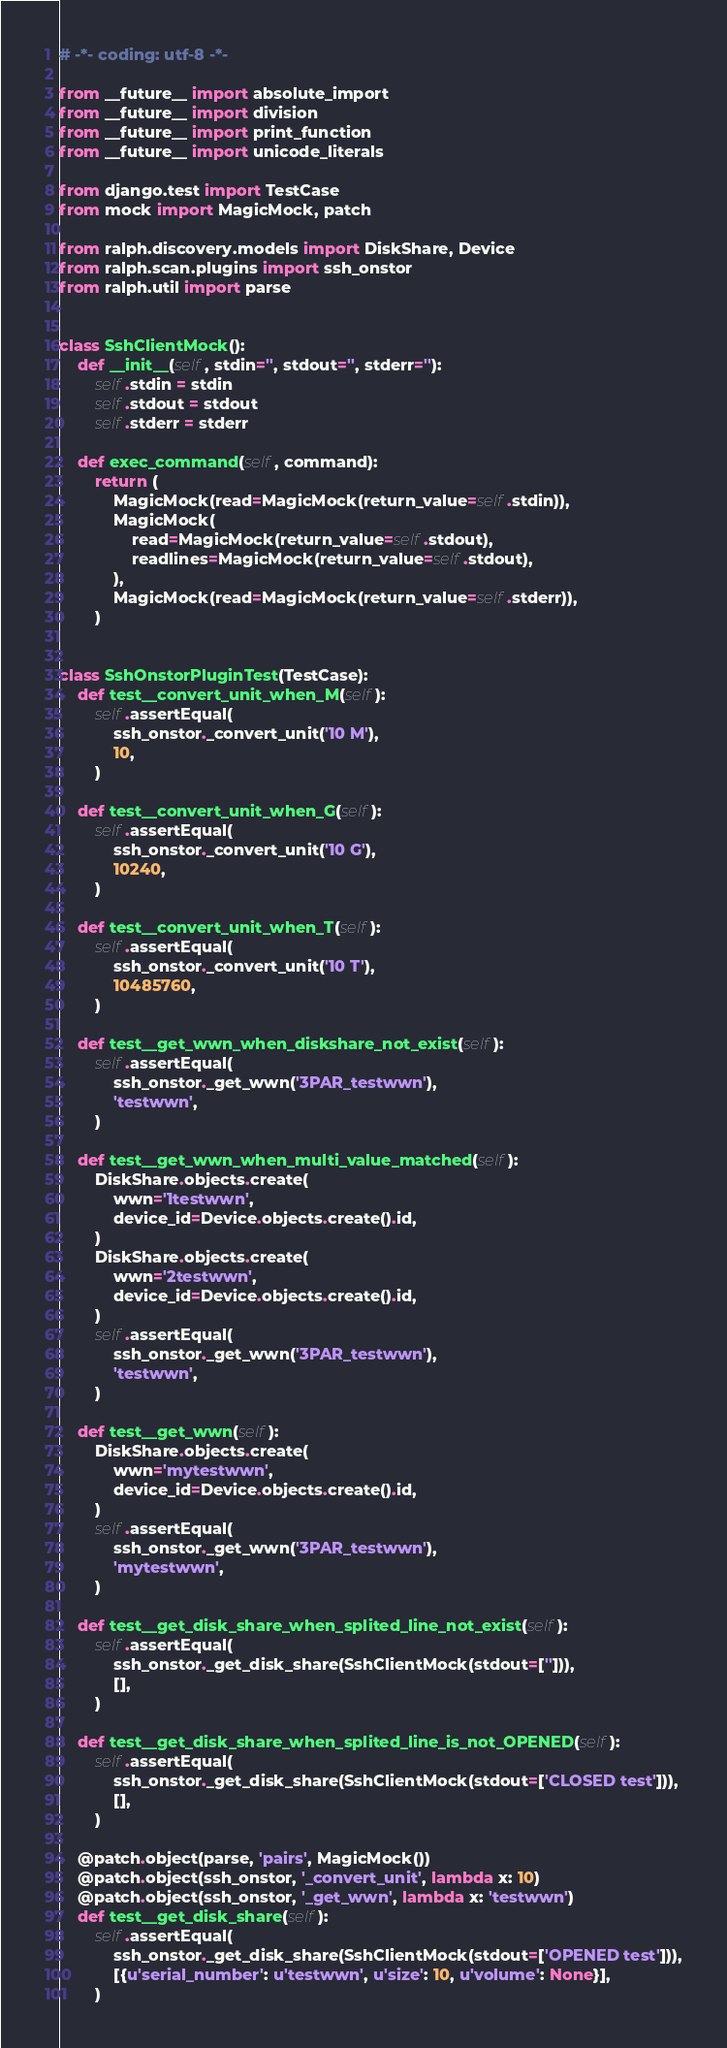Convert code to text. <code><loc_0><loc_0><loc_500><loc_500><_Python_># -*- coding: utf-8 -*-

from __future__ import absolute_import
from __future__ import division
from __future__ import print_function
from __future__ import unicode_literals

from django.test import TestCase
from mock import MagicMock, patch

from ralph.discovery.models import DiskShare, Device
from ralph.scan.plugins import ssh_onstor
from ralph.util import parse


class SshClientMock():
    def __init__(self, stdin='', stdout='', stderr=''):
        self.stdin = stdin
        self.stdout = stdout
        self.stderr = stderr

    def exec_command(self, command):
        return (
            MagicMock(read=MagicMock(return_value=self.stdin)),
            MagicMock(
                read=MagicMock(return_value=self.stdout),
                readlines=MagicMock(return_value=self.stdout),
            ),
            MagicMock(read=MagicMock(return_value=self.stderr)),
        )


class SshOnstorPluginTest(TestCase):
    def test__convert_unit_when_M(self):
        self.assertEqual(
            ssh_onstor._convert_unit('10 M'),
            10,
        )

    def test__convert_unit_when_G(self):
        self.assertEqual(
            ssh_onstor._convert_unit('10 G'),
            10240,
        )

    def test__convert_unit_when_T(self):
        self.assertEqual(
            ssh_onstor._convert_unit('10 T'),
            10485760,
        )

    def test__get_wwn_when_diskshare_not_exist(self):
        self.assertEqual(
            ssh_onstor._get_wwn('3PAR_testwwn'),
            'testwwn',
        )

    def test__get_wwn_when_multi_value_matched(self):
        DiskShare.objects.create(
            wwn='1testwwn',
            device_id=Device.objects.create().id,
        )
        DiskShare.objects.create(
            wwn='2testwwn',
            device_id=Device.objects.create().id,
        )
        self.assertEqual(
            ssh_onstor._get_wwn('3PAR_testwwn'),
            'testwwn',
        )

    def test__get_wwn(self):
        DiskShare.objects.create(
            wwn='mytestwwn',
            device_id=Device.objects.create().id,
        )
        self.assertEqual(
            ssh_onstor._get_wwn('3PAR_testwwn'),
            'mytestwwn',
        )

    def test__get_disk_share_when_splited_line_not_exist(self):
        self.assertEqual(
            ssh_onstor._get_disk_share(SshClientMock(stdout=[''])),
            [],
        )

    def test__get_disk_share_when_splited_line_is_not_OPENED(self):
        self.assertEqual(
            ssh_onstor._get_disk_share(SshClientMock(stdout=['CLOSED test'])),
            [],
        )

    @patch.object(parse, 'pairs', MagicMock())
    @patch.object(ssh_onstor, '_convert_unit', lambda x: 10)
    @patch.object(ssh_onstor, '_get_wwn', lambda x: 'testwwn')
    def test__get_disk_share(self):
        self.assertEqual(
            ssh_onstor._get_disk_share(SshClientMock(stdout=['OPENED test'])),
            [{u'serial_number': u'testwwn', u'size': 10, u'volume': None}],
        )</code> 